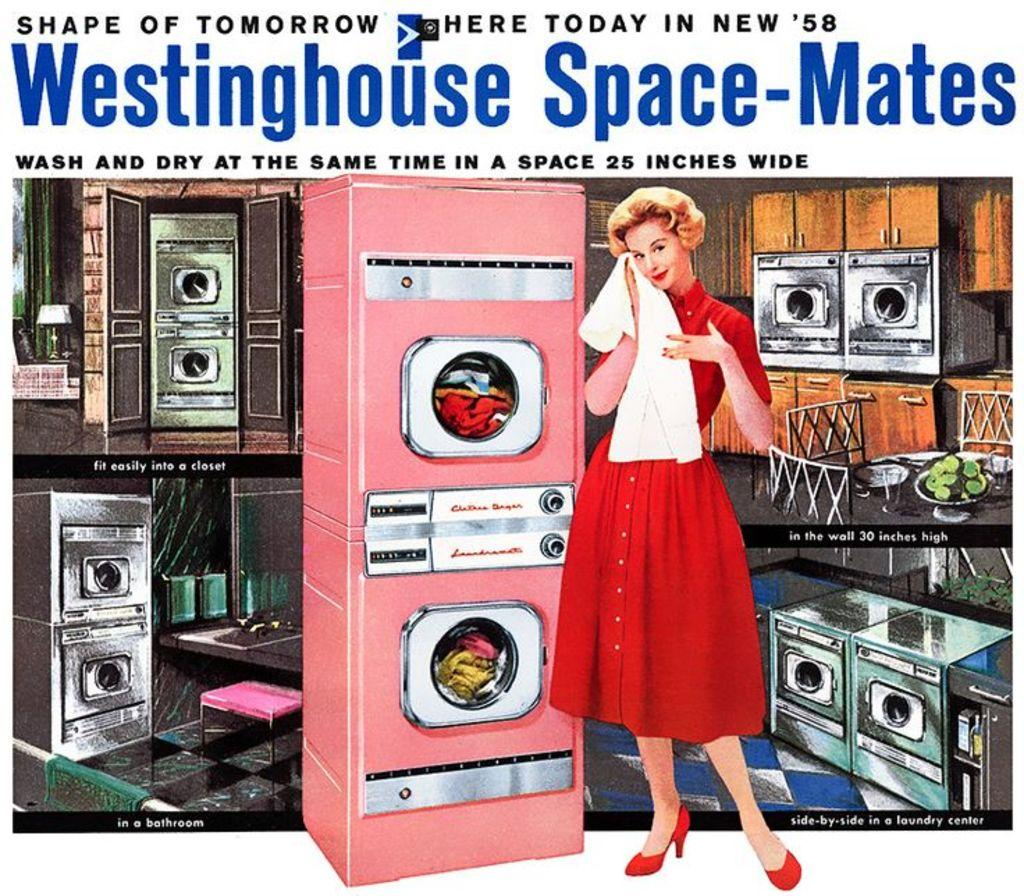What type of image is being described? The image is a poster. Who or what is depicted on the poster? There is a woman on the poster. What is the woman doing in the poster? The woman is standing. What object is the woman holding in the poster? The woman is holding a cloth. How many kites can be seen flying in the background of the poster? There are no kites visible in the background of the poster. 